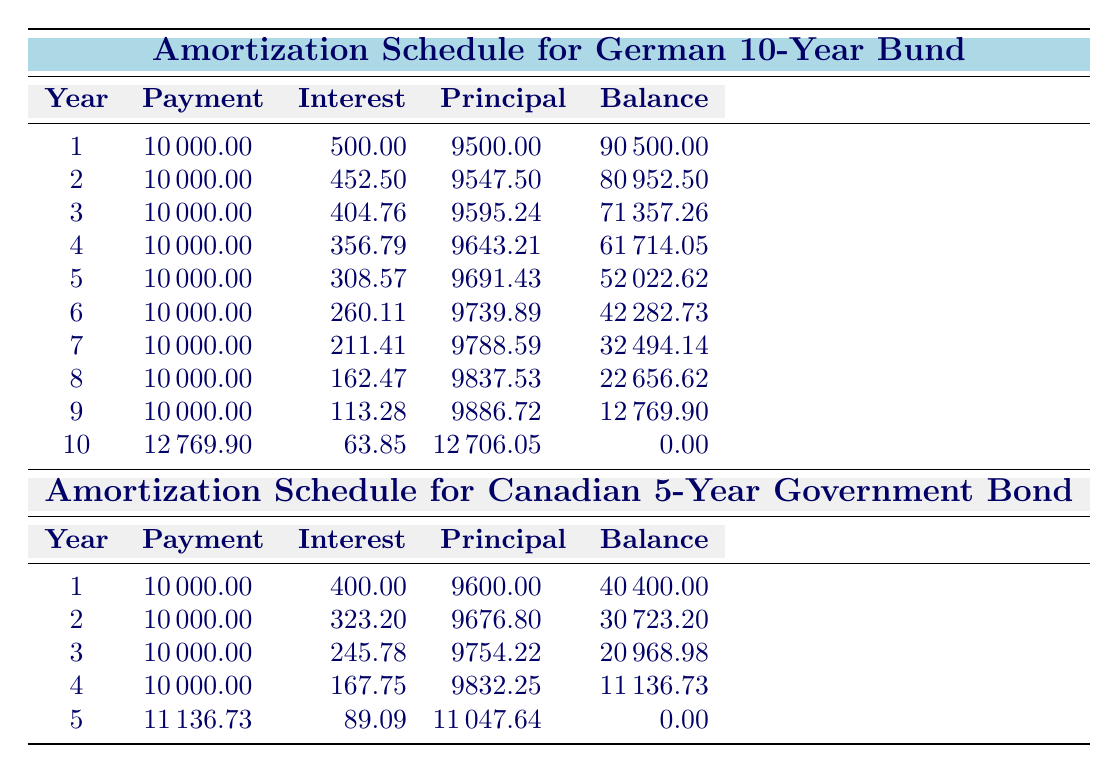What is the total payment made in the first year for the German 10-Year Bund? In the first year, the payment recorded is 10000.00, which is the value indicated directly in the table.
Answer: 10000.00 What is the remaining balance after the second year for the Canadian 5-Year Government Bond? After the second year, the remaining balance is shown as 30723.20 in the amortization schedule for the Canadian bond.
Answer: 30723.20 What is the total interest paid over the life of the German 10-Year Bund? To find the total interest, sum the yearly interest payments: 500.00 + 452.50 + 404.76 + 356.79 + 308.57 + 260.11 + 211.41 + 162.47 + 113.28 + 63.85 = 2269.77.
Answer: 2269.77 Is the principal payment the same for all years of the Canadian 5-Year Government Bond? By examining the table, the principal payments decrease over the years, indicating they are not the same.
Answer: No What is the average annual payment for both the German 10-Year Bund and the Canadian 5-Year Government Bond combined? For the German bond, the total payment is 100000 (initial investment treated as total payment over 10 years) and for the Canadian bond, it's 50000 (total investment over 5 years). Adding them gives 150000. There are 10 payments for German and 5 for Canadian, so average is: 150000 / (10 + 5) = 10000.
Answer: 10000 What was the year with the highest principal payment for the German 10-Year Bund? The principal payment consistently increases throughout the years, examining the table reveals that the highest principal payment is recorded in the last year, at 12706.05.
Answer: 12706.05 What is the difference in the total number of years between the maturity of the German and Canadian bonds? The German 10-Year Bund matures in 10 years, and the Canadian bond matures in 5 years. Thus, the difference is 10 - 5 = 5 years.
Answer: 5 years What was the total remaining balance after the third year for the Canadian 5-Year Government Bond? After the third year, the remaining balance is noted as 20968.98. This value can be found directly in the table.
Answer: 20968.98 What is the principal payment in the final year for the Canadian 5-Year Government Bond? In the fifth year, the principal payment is specified as 11047.64 in the amortization schedule for the Canadian bond.
Answer: 11047.64 